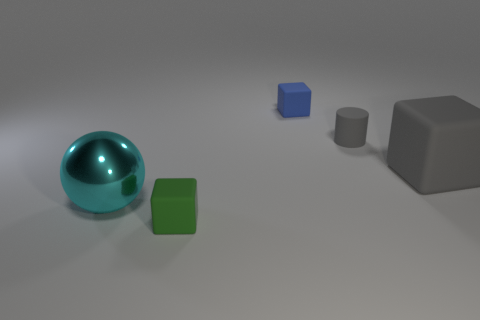Does the gray cube have the same material as the object to the left of the small green thing?
Ensure brevity in your answer.  No. What number of things are big cyan shiny spheres or small green shiny cylinders?
Keep it short and to the point. 1. Is there a small blue metal thing that has the same shape as the large matte thing?
Offer a very short reply. No. How many matte cubes are left of the cylinder?
Give a very brief answer. 2. What is the material of the small object that is on the right side of the tiny block behind the gray matte block?
Provide a short and direct response. Rubber. There is a gray object that is the same size as the cyan metal thing; what is it made of?
Make the answer very short. Rubber. Is there a yellow rubber cylinder that has the same size as the green rubber object?
Your response must be concise. No. What is the color of the tiny object in front of the large cyan metal ball?
Provide a short and direct response. Green. Are there any small blue rubber blocks behind the gray matte thing that is right of the small cylinder?
Your response must be concise. Yes. What number of other things are the same color as the metal thing?
Offer a terse response. 0. 